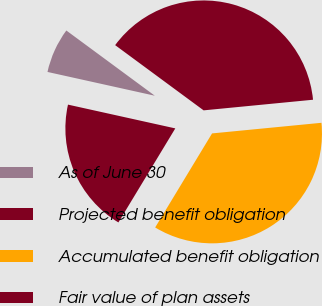<chart> <loc_0><loc_0><loc_500><loc_500><pie_chart><fcel>As of June 30<fcel>Projected benefit obligation<fcel>Accumulated benefit obligation<fcel>Fair value of plan assets<nl><fcel>6.64%<fcel>38.35%<fcel>35.2%<fcel>19.81%<nl></chart> 